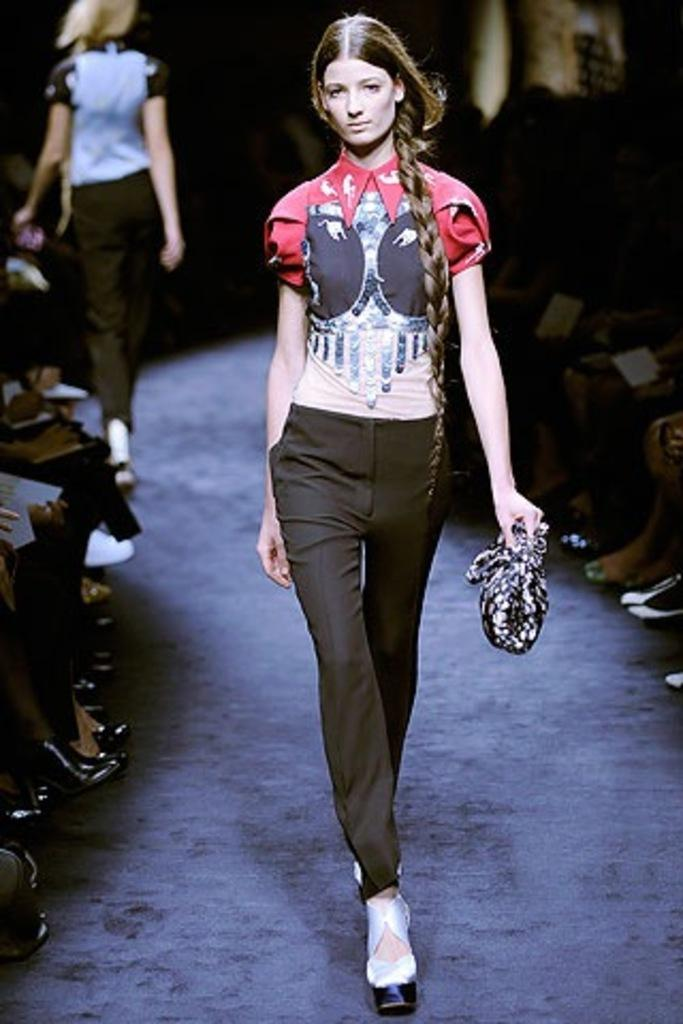What is the main subject of the image? There is a model in the image. What is the model doing in the image? The model is walking on a dais. Are there any other people present in the image? Yes, there are people sitting around the dais. How is the background of the image depicted? The background of the woman is blurred. What type of ring can be seen on the model's finger in the image? There is no ring visible on the model's finger in the image. Is there a tent in the background of the image? There is no tent present in the image; the background is blurred. 